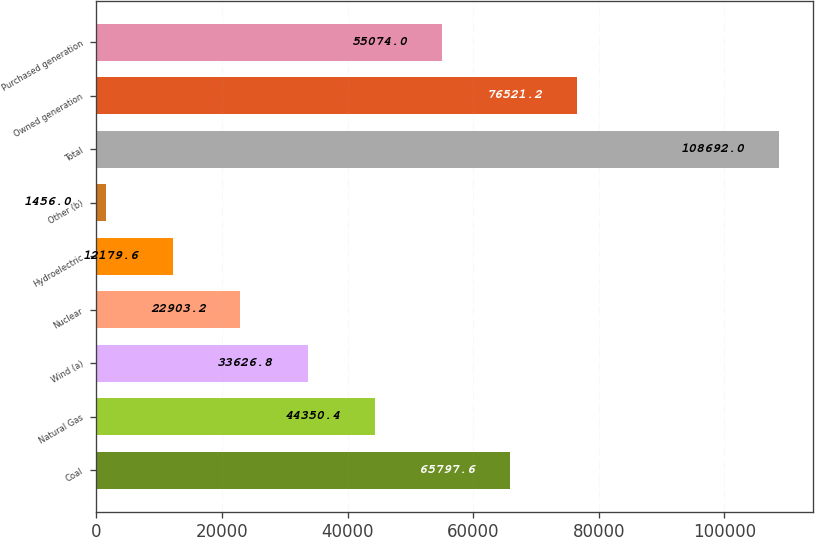Convert chart. <chart><loc_0><loc_0><loc_500><loc_500><bar_chart><fcel>Coal<fcel>Natural Gas<fcel>Wind (a)<fcel>Nuclear<fcel>Hydroelectric<fcel>Other (b)<fcel>Total<fcel>Owned generation<fcel>Purchased generation<nl><fcel>65797.6<fcel>44350.4<fcel>33626.8<fcel>22903.2<fcel>12179.6<fcel>1456<fcel>108692<fcel>76521.2<fcel>55074<nl></chart> 